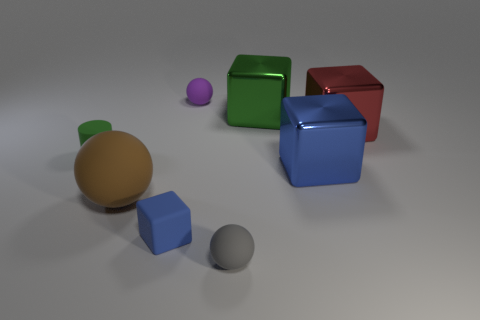Add 2 red metal balls. How many objects exist? 10 Subtract all cylinders. How many objects are left? 7 Add 4 red matte cylinders. How many red matte cylinders exist? 4 Subtract 0 yellow cubes. How many objects are left? 8 Subtract all green matte things. Subtract all green cylinders. How many objects are left? 6 Add 7 tiny gray objects. How many tiny gray objects are left? 8 